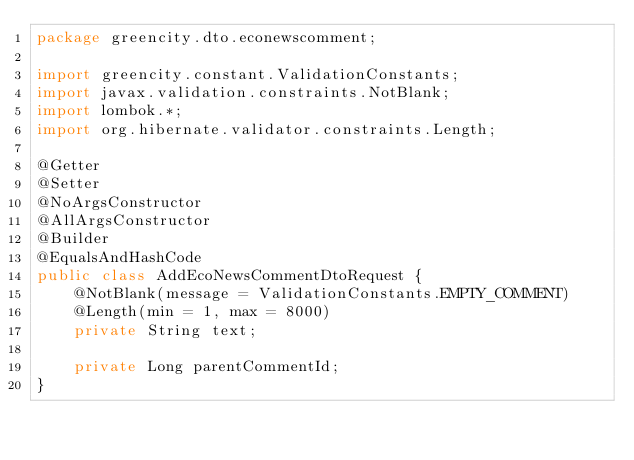Convert code to text. <code><loc_0><loc_0><loc_500><loc_500><_Java_>package greencity.dto.econewscomment;

import greencity.constant.ValidationConstants;
import javax.validation.constraints.NotBlank;
import lombok.*;
import org.hibernate.validator.constraints.Length;

@Getter
@Setter
@NoArgsConstructor
@AllArgsConstructor
@Builder
@EqualsAndHashCode
public class AddEcoNewsCommentDtoRequest {
    @NotBlank(message = ValidationConstants.EMPTY_COMMENT)
    @Length(min = 1, max = 8000)
    private String text;

    private Long parentCommentId;
}
</code> 